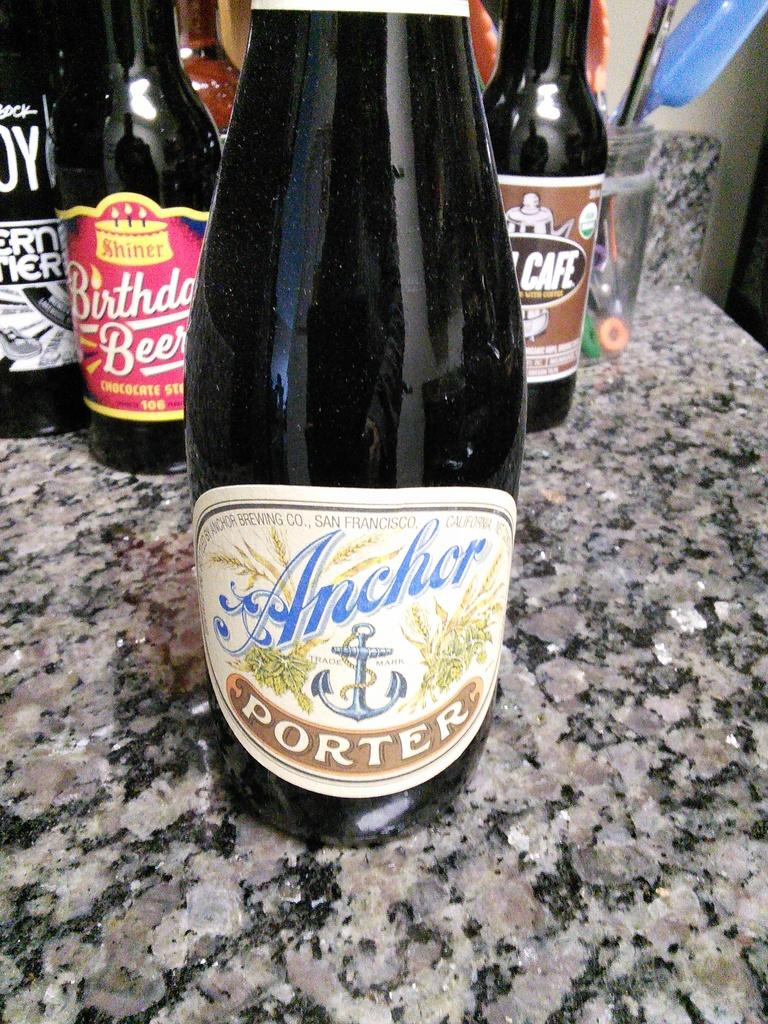Provide a one-sentence caption for the provided image. A bottle that is labelled Anchor Porter is resting on a counter. 